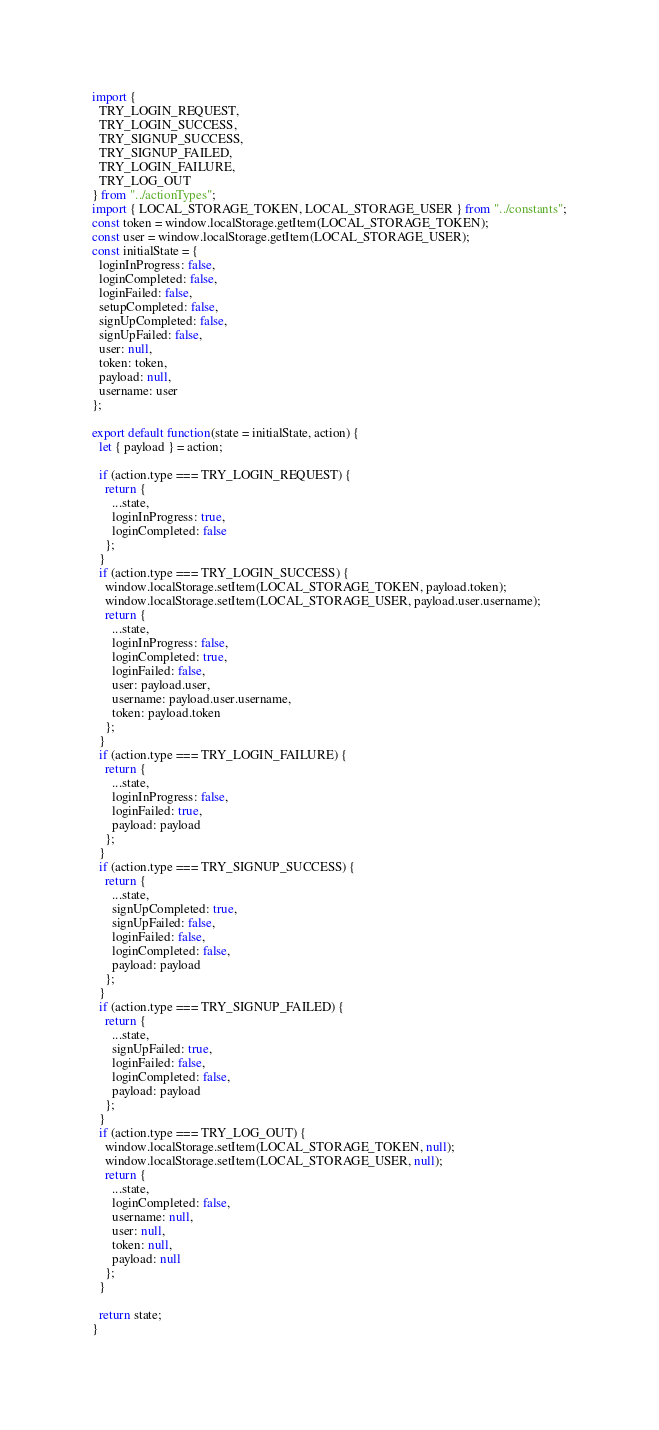<code> <loc_0><loc_0><loc_500><loc_500><_JavaScript_>import {
  TRY_LOGIN_REQUEST,
  TRY_LOGIN_SUCCESS,
  TRY_SIGNUP_SUCCESS,
  TRY_SIGNUP_FAILED,
  TRY_LOGIN_FAILURE,
  TRY_LOG_OUT
} from "../actionTypes";
import { LOCAL_STORAGE_TOKEN, LOCAL_STORAGE_USER } from "../constants";
const token = window.localStorage.getItem(LOCAL_STORAGE_TOKEN);
const user = window.localStorage.getItem(LOCAL_STORAGE_USER);
const initialState = {
  loginInProgress: false,
  loginCompleted: false,
  loginFailed: false,
  setupCompleted: false,
  signUpCompleted: false,
  signUpFailed: false,
  user: null,
  token: token,
  payload: null,
  username: user
};

export default function(state = initialState, action) {
  let { payload } = action;

  if (action.type === TRY_LOGIN_REQUEST) {
    return {
      ...state,
      loginInProgress: true,
      loginCompleted: false
    };
  }
  if (action.type === TRY_LOGIN_SUCCESS) {
    window.localStorage.setItem(LOCAL_STORAGE_TOKEN, payload.token);
    window.localStorage.setItem(LOCAL_STORAGE_USER, payload.user.username);
    return {
      ...state,
      loginInProgress: false,
      loginCompleted: true,
      loginFailed: false,
      user: payload.user,
      username: payload.user.username,
      token: payload.token
    };
  }
  if (action.type === TRY_LOGIN_FAILURE) {
    return {
      ...state,
      loginInProgress: false,
      loginFailed: true,
      payload: payload
    };
  }
  if (action.type === TRY_SIGNUP_SUCCESS) {
    return {
      ...state,
      signUpCompleted: true,
      signUpFailed: false,
      loginFailed: false,
      loginCompleted: false,
      payload: payload
    };
  }
  if (action.type === TRY_SIGNUP_FAILED) {
    return {
      ...state,
      signUpFailed: true,
      loginFailed: false,
      loginCompleted: false,
      payload: payload
    };
  }
  if (action.type === TRY_LOG_OUT) {
    window.localStorage.setItem(LOCAL_STORAGE_TOKEN, null);
    window.localStorage.setItem(LOCAL_STORAGE_USER, null);
    return {
      ...state,
      loginCompleted: false,
      username: null,
      user: null,
      token: null,
      payload: null
    };
  }

  return state;
}
</code> 